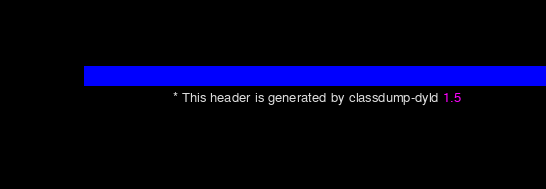<code> <loc_0><loc_0><loc_500><loc_500><_C_>                       * This header is generated by classdump-dyld 1.5</code> 